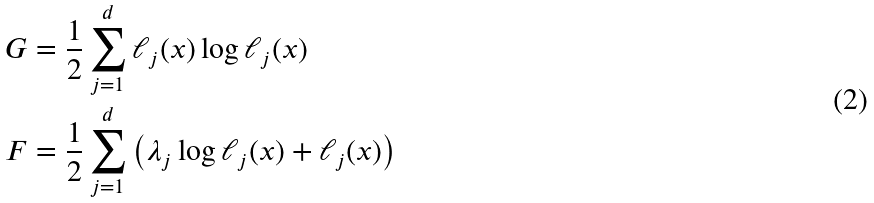<formula> <loc_0><loc_0><loc_500><loc_500>G & = \frac { 1 } { 2 } \sum _ { j = 1 } ^ { d } \ell _ { j } ( x ) \log \ell _ { j } ( x ) \\ F & = \frac { 1 } { 2 } \sum _ { j = 1 } ^ { d } \left ( \lambda _ { j } \log \ell _ { j } ( x ) + \ell _ { j } ( x ) \right )</formula> 